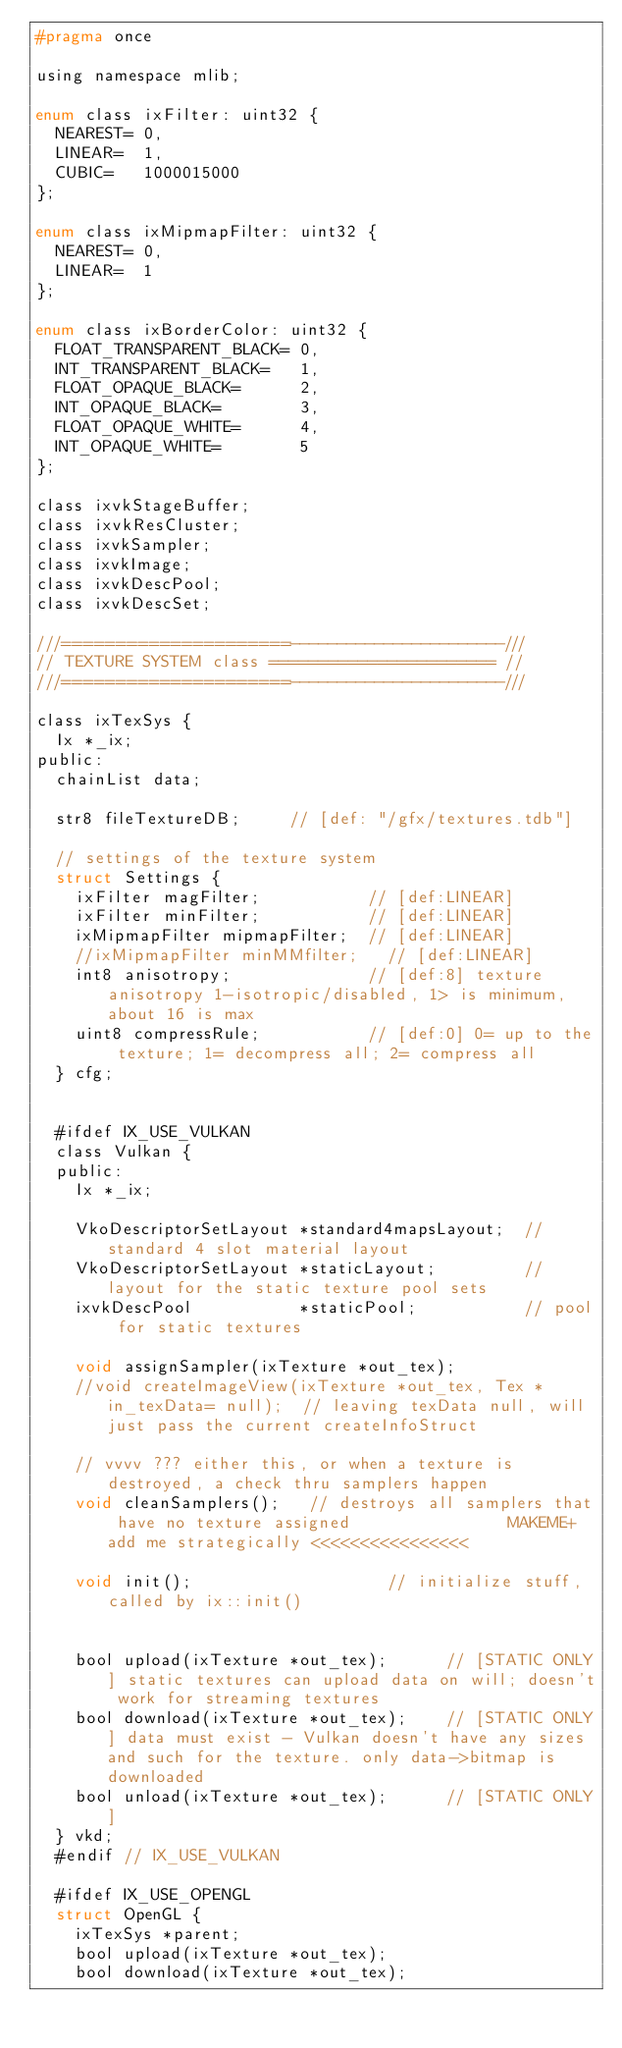<code> <loc_0><loc_0><loc_500><loc_500><_C_>#pragma once

using namespace mlib;

enum class ixFilter: uint32 {
  NEAREST= 0,
  LINEAR=  1,
  CUBIC=   1000015000
};

enum class ixMipmapFilter: uint32 {
  NEAREST= 0,
  LINEAR=  1
};

enum class ixBorderColor: uint32 {
  FLOAT_TRANSPARENT_BLACK= 0,
  INT_TRANSPARENT_BLACK=   1,
  FLOAT_OPAQUE_BLACK=      2,
  INT_OPAQUE_BLACK=        3,
  FLOAT_OPAQUE_WHITE=      4,
  INT_OPAQUE_WHITE=        5
};

class ixvkStageBuffer;
class ixvkResCluster;
class ixvkSampler;
class ixvkImage;
class ixvkDescPool;
class ixvkDescSet;

///=====================-----------------------///
// TEXTURE SYSTEM class ======================= //
///=====================-----------------------///

class ixTexSys {
  Ix *_ix;
public:
  chainList data;

  str8 fileTextureDB;     // [def: "/gfx/textures.tdb"]

  // settings of the texture system
  struct Settings {
    ixFilter magFilter;           // [def:LINEAR]
    ixFilter minFilter;           // [def:LINEAR]
    ixMipmapFilter mipmapFilter;  // [def:LINEAR]
    //ixMipmapFilter minMMfilter;   // [def:LINEAR]
    int8 anisotropy;              // [def:8] texture anisotropy 1-isotropic/disabled, 1> is minimum, about 16 is max
    uint8 compressRule;           // [def:0] 0= up to the texture; 1= decompress all; 2= compress all
  } cfg;


  #ifdef IX_USE_VULKAN
  class Vulkan {
  public:
    Ix *_ix;

    VkoDescriptorSetLayout *standard4mapsLayout;  // standard 4 slot material layout
    VkoDescriptorSetLayout *staticLayout;         // layout for the static texture pool sets
    ixvkDescPool           *staticPool;           // pool for static textures

    void assignSampler(ixTexture *out_tex);
    //void createImageView(ixTexture *out_tex, Tex *in_texData= null);  // leaving texData null, will just pass the current createInfoStruct

    // vvvv ??? either this, or when a texture is destroyed, a check thru samplers happen
    void cleanSamplers();   // destroys all samplers that have no texture assigned                MAKEME+add me strategically <<<<<<<<<<<<<<<<

    void init();                    // initialize stuff, called by ix::init()


    bool upload(ixTexture *out_tex);      // [STATIC ONLY] static textures can upload data on will; doesn't work for streaming textures
    bool download(ixTexture *out_tex);    // [STATIC ONLY] data must exist - Vulkan doesn't have any sizes and such for the texture. only data->bitmap is downloaded
    bool unload(ixTexture *out_tex);      // [STATIC ONLY]
  } vkd;
  #endif // IX_USE_VULKAN

  #ifdef IX_USE_OPENGL
  struct OpenGL {
    ixTexSys *parent;
    bool upload(ixTexture *out_tex);
    bool download(ixTexture *out_tex);</code> 